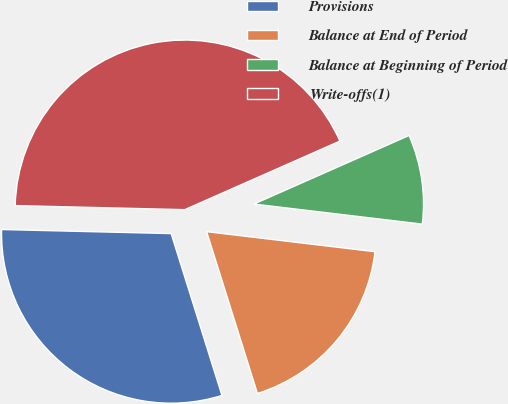<chart> <loc_0><loc_0><loc_500><loc_500><pie_chart><fcel>Provisions<fcel>Balance at End of Period<fcel>Balance at Beginning of Period<fcel>Write-offs(1)<nl><fcel>30.22%<fcel>18.27%<fcel>8.51%<fcel>42.99%<nl></chart> 